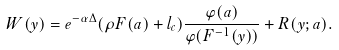Convert formula to latex. <formula><loc_0><loc_0><loc_500><loc_500>W ( y ) = e ^ { - \alpha \Delta } ( \rho F ( a ) + l _ { c } ) \frac { \varphi ( a ) } { \varphi ( F ^ { - 1 } ( y ) ) } + R ( y ; a ) .</formula> 